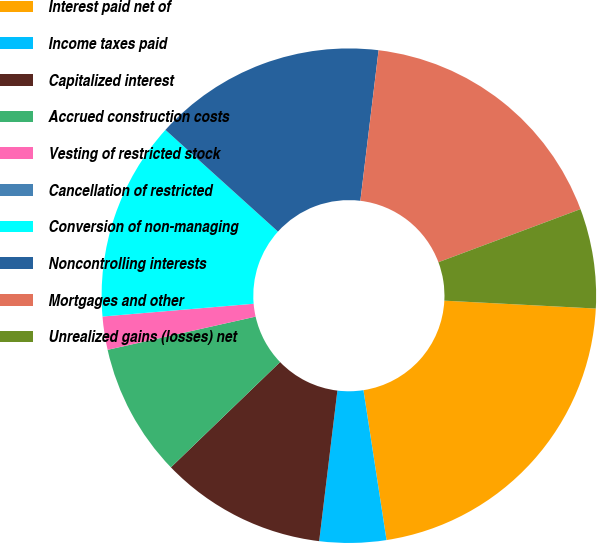<chart> <loc_0><loc_0><loc_500><loc_500><pie_chart><fcel>Interest paid net of<fcel>Income taxes paid<fcel>Capitalized interest<fcel>Accrued construction costs<fcel>Vesting of restricted stock<fcel>Cancellation of restricted<fcel>Conversion of non-managing<fcel>Noncontrolling interests<fcel>Mortgages and other<fcel>Unrealized gains (losses) net<nl><fcel>21.74%<fcel>4.35%<fcel>10.87%<fcel>8.7%<fcel>2.17%<fcel>0.0%<fcel>13.04%<fcel>15.22%<fcel>17.39%<fcel>6.52%<nl></chart> 